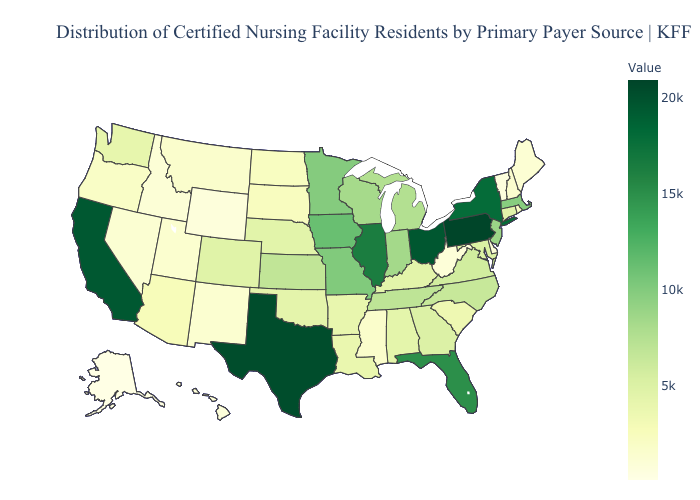Which states have the lowest value in the Northeast?
Quick response, please. Vermont. Which states have the lowest value in the MidWest?
Short answer required. North Dakota. Among the states that border Oregon , which have the lowest value?
Write a very short answer. Idaho. Among the states that border Florida , does Georgia have the highest value?
Concise answer only. Yes. Among the states that border Connecticut , which have the lowest value?
Quick response, please. Rhode Island. Among the states that border Alabama , does Tennessee have the lowest value?
Concise answer only. No. Which states have the lowest value in the South?
Quick response, please. West Virginia. Does Arkansas have the lowest value in the South?
Concise answer only. No. 